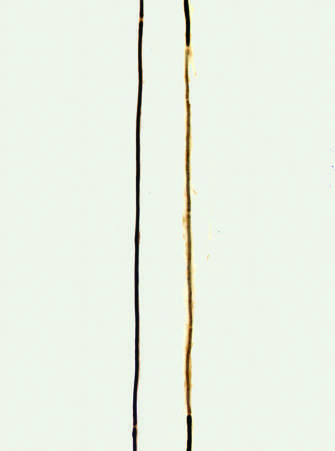what allow for examination of individual axons of peripheral nerves?
Answer the question using a single word or phrase. Teased fiber preparations 